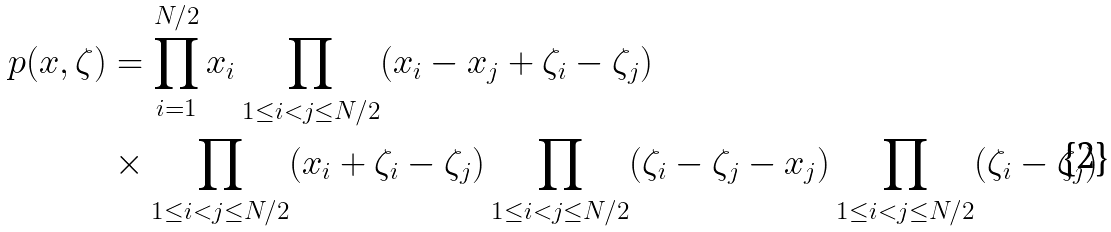Convert formula to latex. <formula><loc_0><loc_0><loc_500><loc_500>p ( x , \zeta ) & = \prod _ { i = 1 } ^ { N / 2 } x _ { i } \prod _ { 1 \leq i < j \leq N / 2 } ( x _ { i } - x _ { j } + \zeta _ { i } - \zeta _ { j } ) \\ & \times \prod _ { 1 \leq i < j \leq N / 2 } ( x _ { i } + \zeta _ { i } - \zeta _ { j } ) \prod _ { 1 \leq i < j \leq N / 2 } ( \zeta _ { i } - \zeta _ { j } - x _ { j } ) \prod _ { 1 \leq i < j \leq N / 2 } ( \zeta _ { i } - \zeta _ { j } )</formula> 